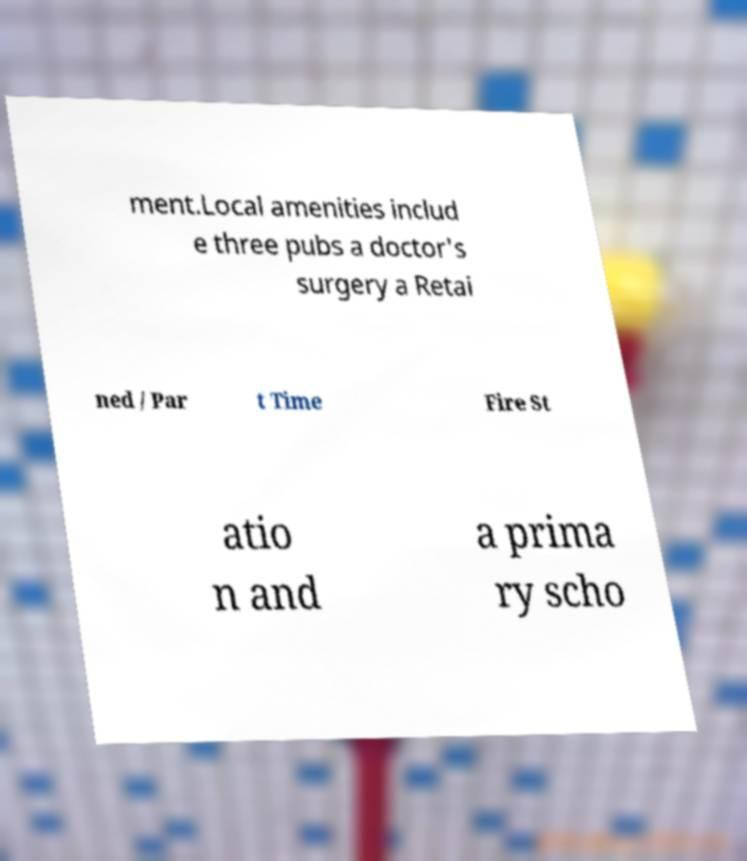Can you accurately transcribe the text from the provided image for me? ment.Local amenities includ e three pubs a doctor's surgery a Retai ned / Par t Time Fire St atio n and a prima ry scho 